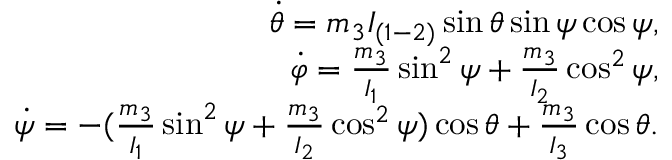<formula> <loc_0><loc_0><loc_500><loc_500>\begin{array} { r } { \dot { \theta } = m _ { 3 } I _ { ( 1 - 2 ) } \sin \theta \sin \psi \cos \psi , } \\ { \dot { \varphi } = \frac { m _ { 3 } } { I _ { 1 } } \sin ^ { 2 } \psi + \frac { m _ { 3 } } { I _ { 2 } } \cos ^ { 2 } \psi , } \\ { \dot { \psi } = - ( \frac { m _ { 3 } } { I _ { 1 } } \sin ^ { 2 } \psi + \frac { m _ { 3 } } { I _ { 2 } } \cos ^ { 2 } \psi ) \cos \theta + \frac { m _ { 3 } } { I _ { 3 } } \cos \theta . } \end{array}</formula> 